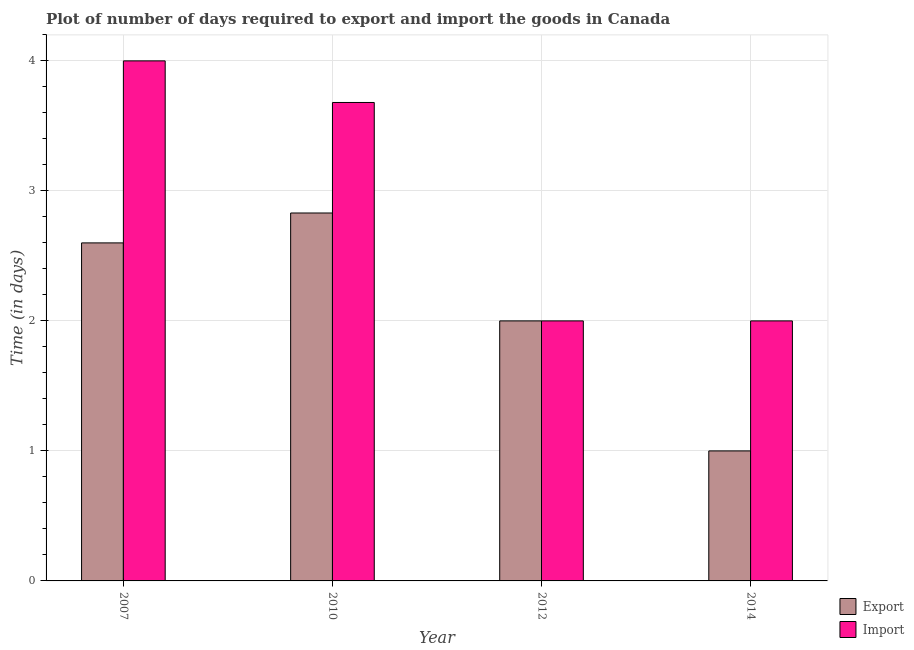How many groups of bars are there?
Provide a succinct answer. 4. Are the number of bars on each tick of the X-axis equal?
Keep it short and to the point. Yes. In how many cases, is the number of bars for a given year not equal to the number of legend labels?
Keep it short and to the point. 0. What is the time required to export in 2007?
Provide a succinct answer. 2.6. Across all years, what is the maximum time required to import?
Give a very brief answer. 4. In which year was the time required to import maximum?
Your answer should be compact. 2007. What is the total time required to import in the graph?
Give a very brief answer. 11.68. What is the difference between the time required to export in 2010 and that in 2014?
Your response must be concise. 1.83. What is the average time required to export per year?
Keep it short and to the point. 2.11. Is the time required to import in 2007 less than that in 2012?
Ensure brevity in your answer.  No. Is the difference between the time required to import in 2007 and 2012 greater than the difference between the time required to export in 2007 and 2012?
Offer a very short reply. No. What is the difference between the highest and the second highest time required to import?
Keep it short and to the point. 0.32. What is the difference between the highest and the lowest time required to export?
Your response must be concise. 1.83. In how many years, is the time required to export greater than the average time required to export taken over all years?
Your answer should be compact. 2. Is the sum of the time required to export in 2012 and 2014 greater than the maximum time required to import across all years?
Give a very brief answer. Yes. What does the 1st bar from the left in 2012 represents?
Make the answer very short. Export. What does the 1st bar from the right in 2007 represents?
Your response must be concise. Import. How many bars are there?
Keep it short and to the point. 8. Are all the bars in the graph horizontal?
Your answer should be compact. No. What is the difference between two consecutive major ticks on the Y-axis?
Give a very brief answer. 1. Where does the legend appear in the graph?
Offer a terse response. Bottom right. How are the legend labels stacked?
Offer a terse response. Vertical. What is the title of the graph?
Give a very brief answer. Plot of number of days required to export and import the goods in Canada. Does "Under-five" appear as one of the legend labels in the graph?
Your response must be concise. No. What is the label or title of the Y-axis?
Your response must be concise. Time (in days). What is the Time (in days) in Export in 2010?
Ensure brevity in your answer.  2.83. What is the Time (in days) of Import in 2010?
Offer a very short reply. 3.68. What is the Time (in days) of Import in 2012?
Keep it short and to the point. 2. Across all years, what is the maximum Time (in days) in Export?
Offer a very short reply. 2.83. Across all years, what is the maximum Time (in days) of Import?
Offer a terse response. 4. Across all years, what is the minimum Time (in days) in Export?
Your response must be concise. 1. Across all years, what is the minimum Time (in days) in Import?
Offer a very short reply. 2. What is the total Time (in days) of Export in the graph?
Make the answer very short. 8.43. What is the total Time (in days) of Import in the graph?
Your answer should be compact. 11.68. What is the difference between the Time (in days) of Export in 2007 and that in 2010?
Offer a terse response. -0.23. What is the difference between the Time (in days) in Import in 2007 and that in 2010?
Keep it short and to the point. 0.32. What is the difference between the Time (in days) in Import in 2007 and that in 2012?
Ensure brevity in your answer.  2. What is the difference between the Time (in days) in Import in 2007 and that in 2014?
Your response must be concise. 2. What is the difference between the Time (in days) of Export in 2010 and that in 2012?
Provide a succinct answer. 0.83. What is the difference between the Time (in days) of Import in 2010 and that in 2012?
Your response must be concise. 1.68. What is the difference between the Time (in days) of Export in 2010 and that in 2014?
Give a very brief answer. 1.83. What is the difference between the Time (in days) in Import in 2010 and that in 2014?
Make the answer very short. 1.68. What is the difference between the Time (in days) in Export in 2012 and that in 2014?
Your answer should be very brief. 1. What is the difference between the Time (in days) in Export in 2007 and the Time (in days) in Import in 2010?
Offer a very short reply. -1.08. What is the difference between the Time (in days) in Export in 2007 and the Time (in days) in Import in 2012?
Provide a short and direct response. 0.6. What is the difference between the Time (in days) in Export in 2007 and the Time (in days) in Import in 2014?
Offer a terse response. 0.6. What is the difference between the Time (in days) of Export in 2010 and the Time (in days) of Import in 2012?
Your answer should be compact. 0.83. What is the difference between the Time (in days) in Export in 2010 and the Time (in days) in Import in 2014?
Ensure brevity in your answer.  0.83. What is the difference between the Time (in days) of Export in 2012 and the Time (in days) of Import in 2014?
Give a very brief answer. 0. What is the average Time (in days) in Export per year?
Provide a succinct answer. 2.11. What is the average Time (in days) in Import per year?
Make the answer very short. 2.92. In the year 2010, what is the difference between the Time (in days) in Export and Time (in days) in Import?
Your answer should be very brief. -0.85. In the year 2014, what is the difference between the Time (in days) in Export and Time (in days) in Import?
Ensure brevity in your answer.  -1. What is the ratio of the Time (in days) of Export in 2007 to that in 2010?
Your answer should be compact. 0.92. What is the ratio of the Time (in days) of Import in 2007 to that in 2010?
Provide a succinct answer. 1.09. What is the ratio of the Time (in days) in Export in 2007 to that in 2012?
Your answer should be very brief. 1.3. What is the ratio of the Time (in days) in Export in 2007 to that in 2014?
Make the answer very short. 2.6. What is the ratio of the Time (in days) in Import in 2007 to that in 2014?
Keep it short and to the point. 2. What is the ratio of the Time (in days) of Export in 2010 to that in 2012?
Provide a succinct answer. 1.42. What is the ratio of the Time (in days) of Import in 2010 to that in 2012?
Your response must be concise. 1.84. What is the ratio of the Time (in days) in Export in 2010 to that in 2014?
Provide a succinct answer. 2.83. What is the ratio of the Time (in days) of Import in 2010 to that in 2014?
Your answer should be compact. 1.84. What is the difference between the highest and the second highest Time (in days) in Export?
Provide a short and direct response. 0.23. What is the difference between the highest and the second highest Time (in days) in Import?
Your answer should be very brief. 0.32. What is the difference between the highest and the lowest Time (in days) of Export?
Make the answer very short. 1.83. What is the difference between the highest and the lowest Time (in days) of Import?
Give a very brief answer. 2. 